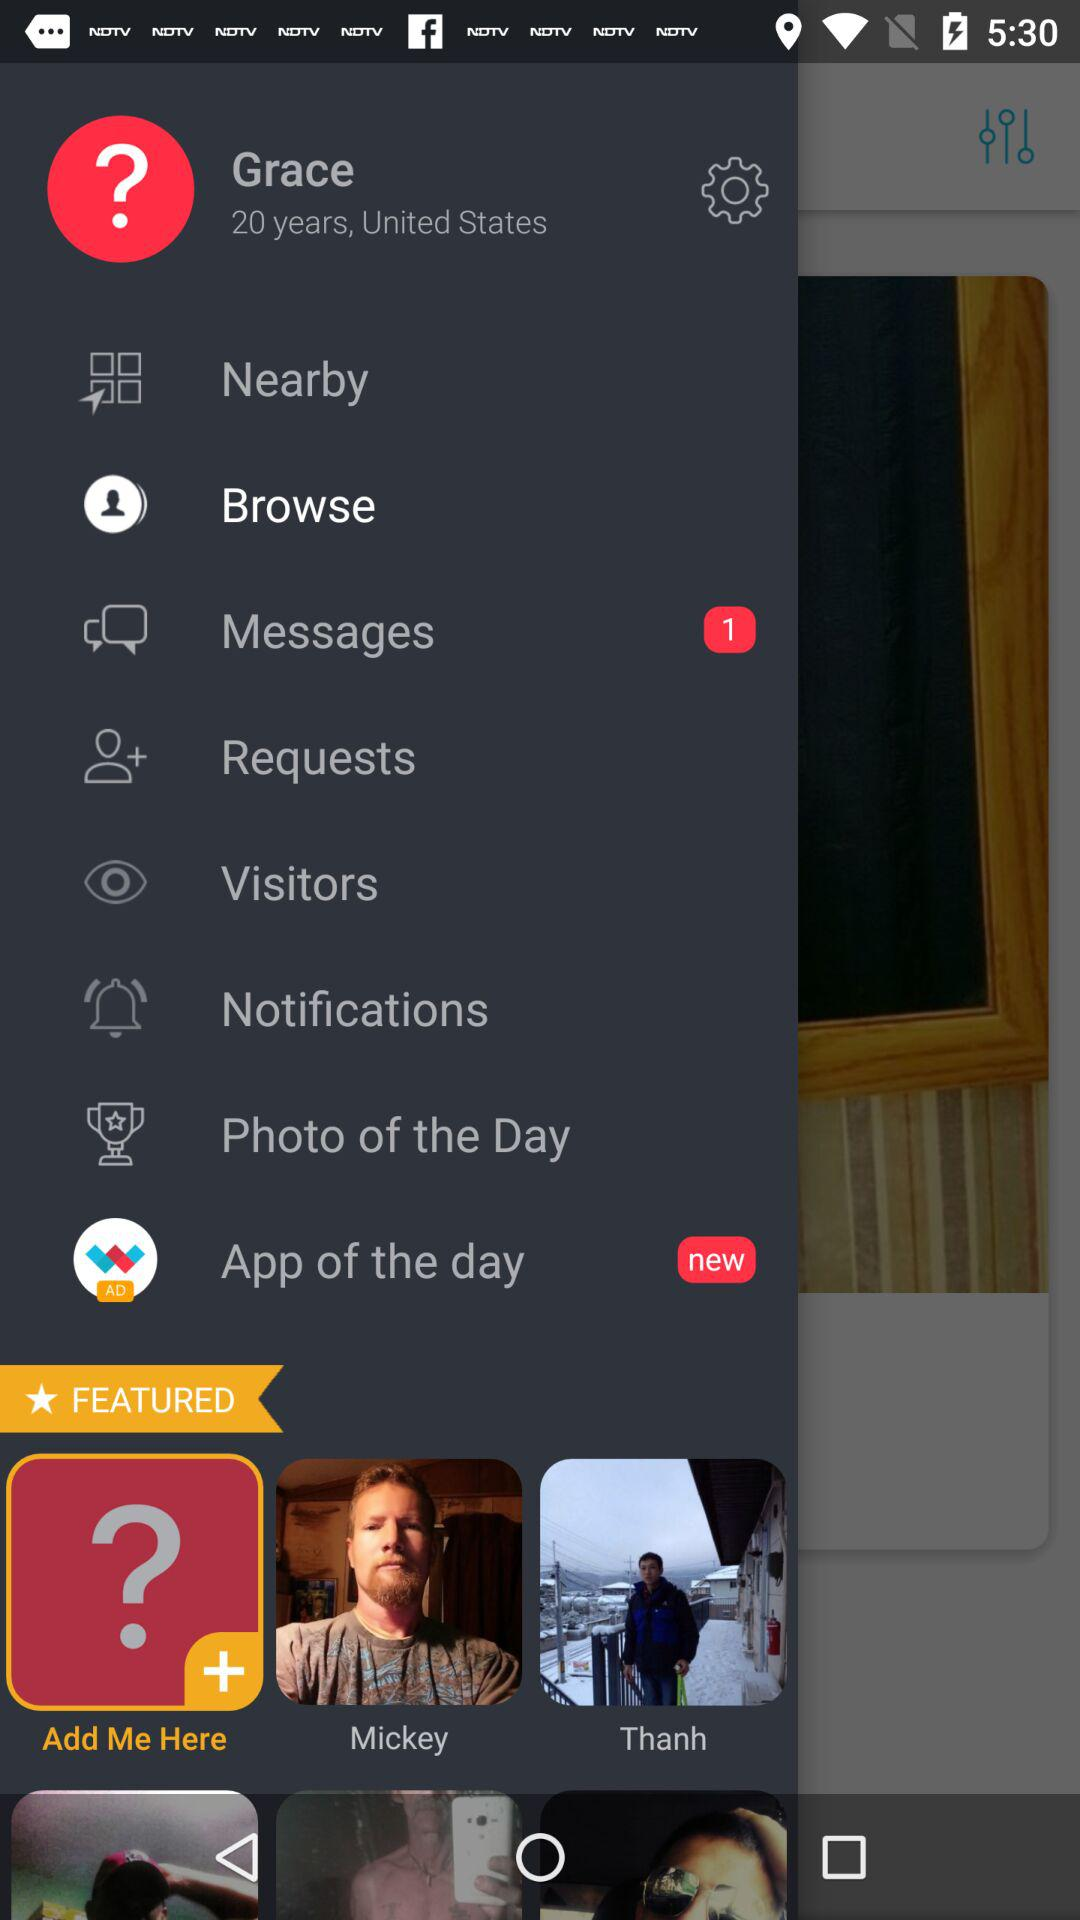What is the name of the country? The name of the country is the United States. 